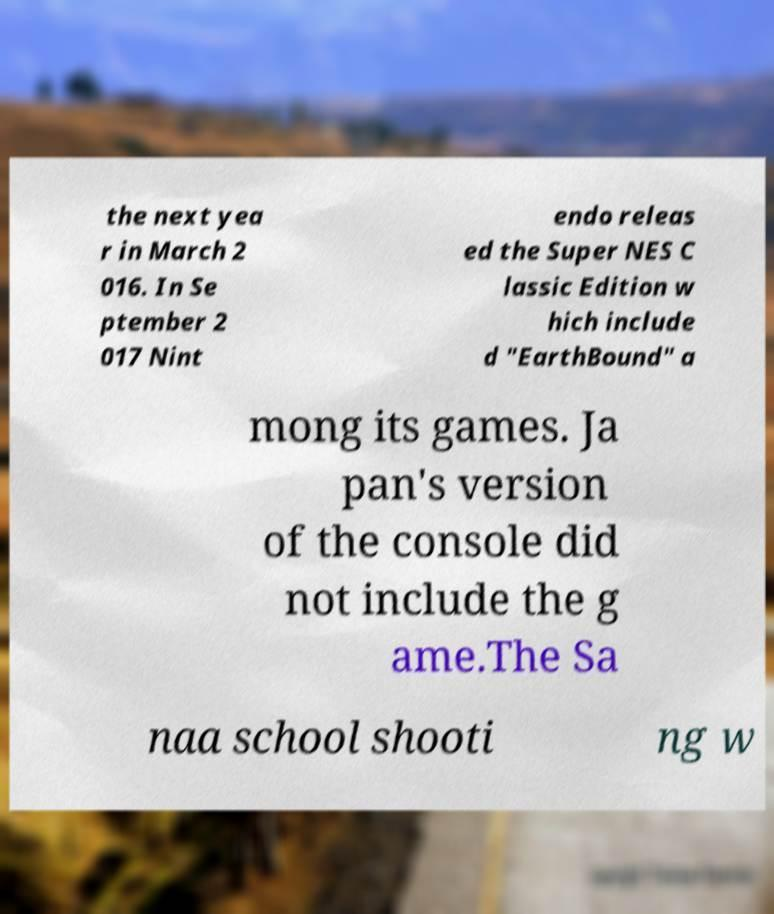For documentation purposes, I need the text within this image transcribed. Could you provide that? the next yea r in March 2 016. In Se ptember 2 017 Nint endo releas ed the Super NES C lassic Edition w hich include d "EarthBound" a mong its games. Ja pan's version of the console did not include the g ame.The Sa naa school shooti ng w 